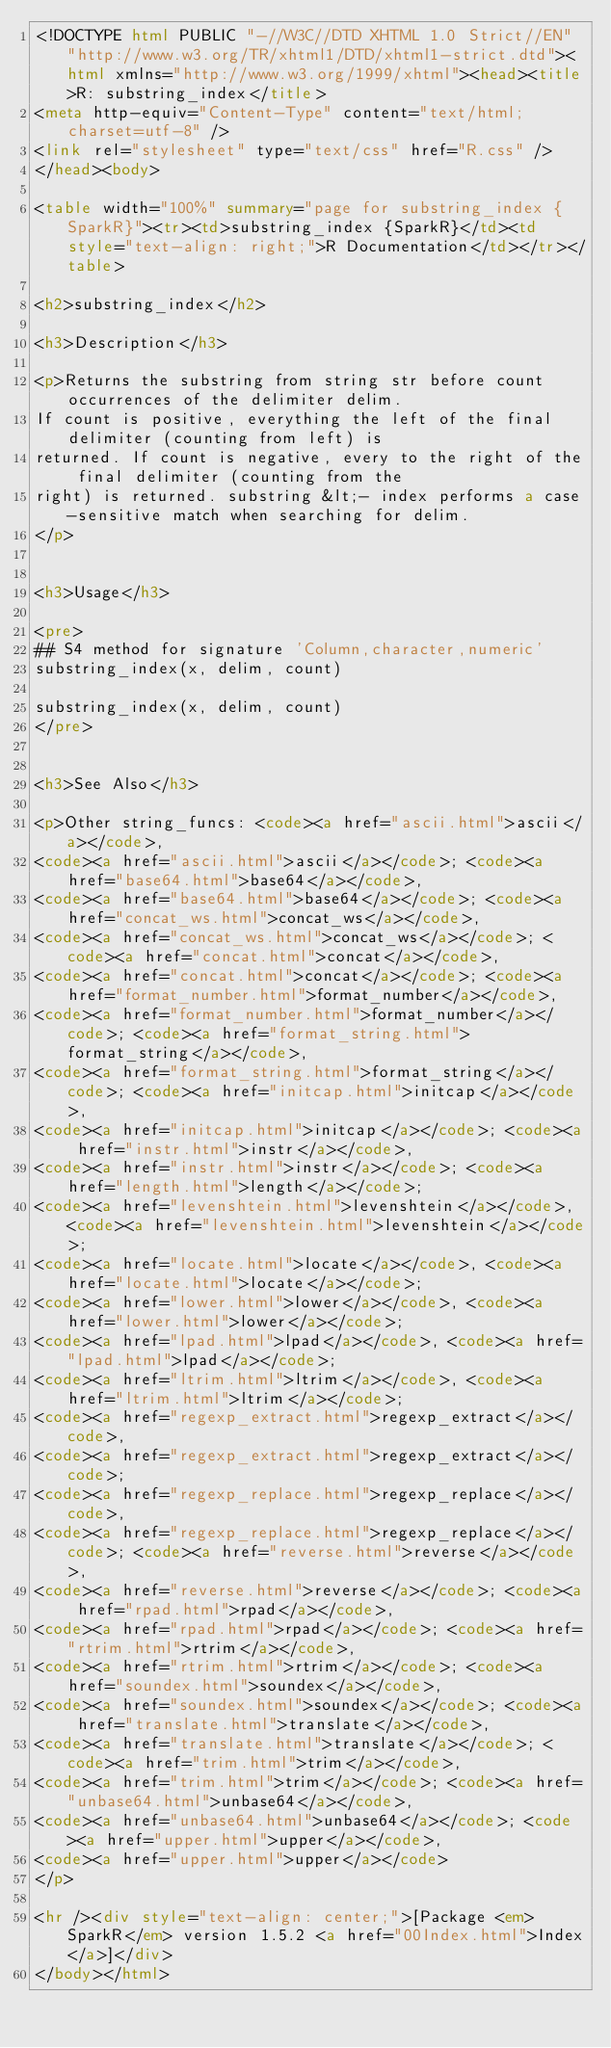<code> <loc_0><loc_0><loc_500><loc_500><_HTML_><!DOCTYPE html PUBLIC "-//W3C//DTD XHTML 1.0 Strict//EN" "http://www.w3.org/TR/xhtml1/DTD/xhtml1-strict.dtd"><html xmlns="http://www.w3.org/1999/xhtml"><head><title>R: substring_index</title>
<meta http-equiv="Content-Type" content="text/html; charset=utf-8" />
<link rel="stylesheet" type="text/css" href="R.css" />
</head><body>

<table width="100%" summary="page for substring_index {SparkR}"><tr><td>substring_index {SparkR}</td><td style="text-align: right;">R Documentation</td></tr></table>

<h2>substring_index</h2>

<h3>Description</h3>

<p>Returns the substring from string str before count occurrences of the delimiter delim.
If count is positive, everything the left of the final delimiter (counting from left) is
returned. If count is negative, every to the right of the final delimiter (counting from the
right) is returned. substring &lt;- index performs a case-sensitive match when searching for delim.
</p>


<h3>Usage</h3>

<pre>
## S4 method for signature 'Column,character,numeric'
substring_index(x, delim, count)

substring_index(x, delim, count)
</pre>


<h3>See Also</h3>

<p>Other string_funcs: <code><a href="ascii.html">ascii</a></code>,
<code><a href="ascii.html">ascii</a></code>; <code><a href="base64.html">base64</a></code>,
<code><a href="base64.html">base64</a></code>; <code><a href="concat_ws.html">concat_ws</a></code>,
<code><a href="concat_ws.html">concat_ws</a></code>; <code><a href="concat.html">concat</a></code>,
<code><a href="concat.html">concat</a></code>; <code><a href="format_number.html">format_number</a></code>,
<code><a href="format_number.html">format_number</a></code>; <code><a href="format_string.html">format_string</a></code>,
<code><a href="format_string.html">format_string</a></code>; <code><a href="initcap.html">initcap</a></code>,
<code><a href="initcap.html">initcap</a></code>; <code><a href="instr.html">instr</a></code>,
<code><a href="instr.html">instr</a></code>; <code><a href="length.html">length</a></code>;
<code><a href="levenshtein.html">levenshtein</a></code>, <code><a href="levenshtein.html">levenshtein</a></code>;
<code><a href="locate.html">locate</a></code>, <code><a href="locate.html">locate</a></code>;
<code><a href="lower.html">lower</a></code>, <code><a href="lower.html">lower</a></code>;
<code><a href="lpad.html">lpad</a></code>, <code><a href="lpad.html">lpad</a></code>;
<code><a href="ltrim.html">ltrim</a></code>, <code><a href="ltrim.html">ltrim</a></code>;
<code><a href="regexp_extract.html">regexp_extract</a></code>,
<code><a href="regexp_extract.html">regexp_extract</a></code>;
<code><a href="regexp_replace.html">regexp_replace</a></code>,
<code><a href="regexp_replace.html">regexp_replace</a></code>; <code><a href="reverse.html">reverse</a></code>,
<code><a href="reverse.html">reverse</a></code>; <code><a href="rpad.html">rpad</a></code>,
<code><a href="rpad.html">rpad</a></code>; <code><a href="rtrim.html">rtrim</a></code>,
<code><a href="rtrim.html">rtrim</a></code>; <code><a href="soundex.html">soundex</a></code>,
<code><a href="soundex.html">soundex</a></code>; <code><a href="translate.html">translate</a></code>,
<code><a href="translate.html">translate</a></code>; <code><a href="trim.html">trim</a></code>,
<code><a href="trim.html">trim</a></code>; <code><a href="unbase64.html">unbase64</a></code>,
<code><a href="unbase64.html">unbase64</a></code>; <code><a href="upper.html">upper</a></code>,
<code><a href="upper.html">upper</a></code>
</p>

<hr /><div style="text-align: center;">[Package <em>SparkR</em> version 1.5.2 <a href="00Index.html">Index</a>]</div>
</body></html>
</code> 